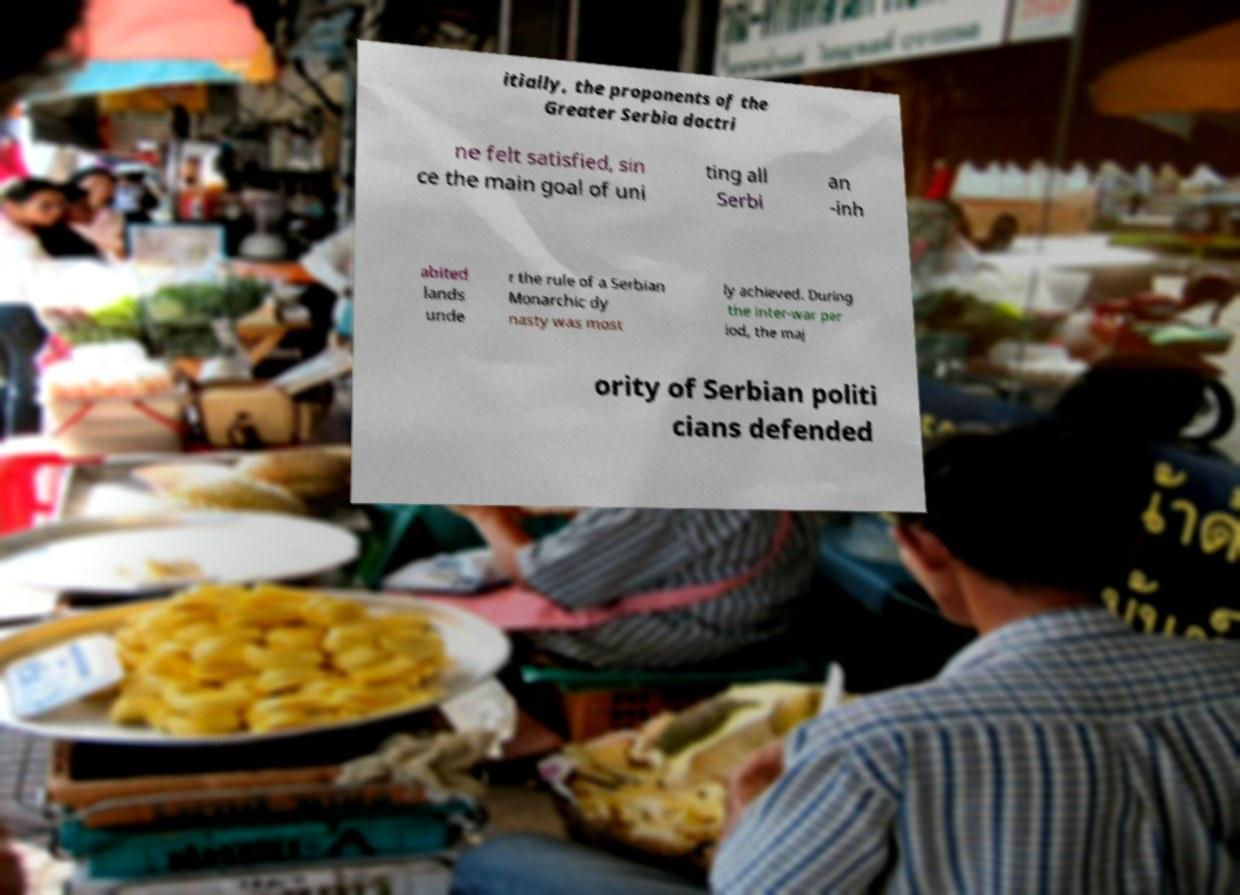For documentation purposes, I need the text within this image transcribed. Could you provide that? itially, the proponents of the Greater Serbia doctri ne felt satisfied, sin ce the main goal of uni ting all Serbi an -inh abited lands unde r the rule of a Serbian Monarchic dy nasty was most ly achieved. During the inter-war per iod, the maj ority of Serbian politi cians defended 